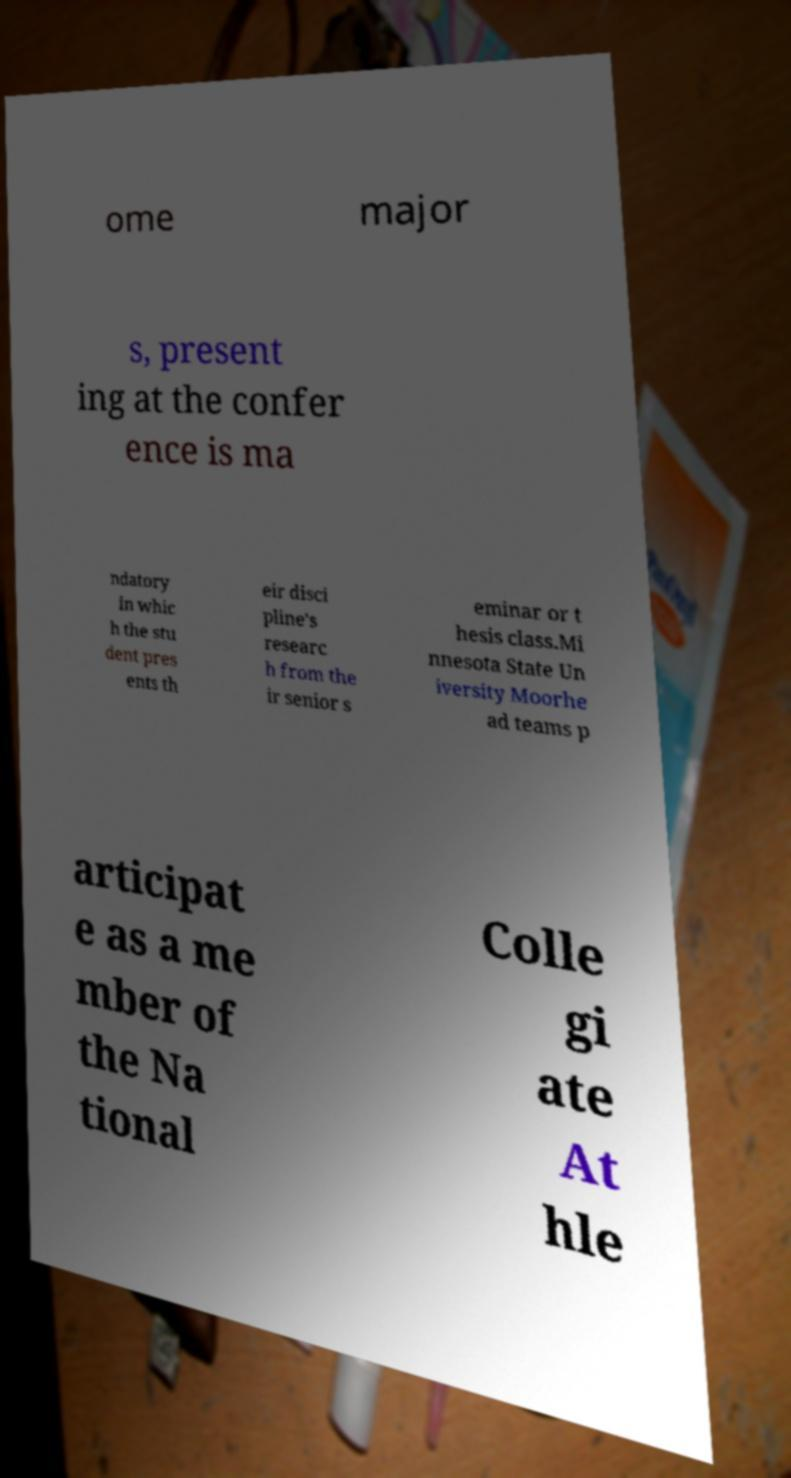Could you assist in decoding the text presented in this image and type it out clearly? ome major s, present ing at the confer ence is ma ndatory in whic h the stu dent pres ents th eir disci pline's researc h from the ir senior s eminar or t hesis class.Mi nnesota State Un iversity Moorhe ad teams p articipat e as a me mber of the Na tional Colle gi ate At hle 